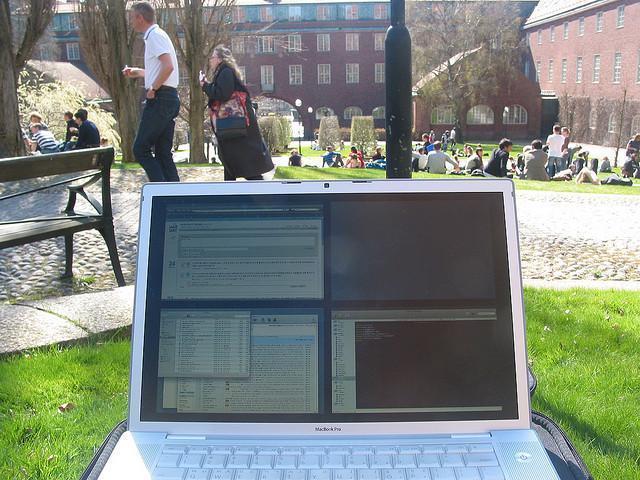Where is this lap top set up?
Select the correct answer and articulate reasoning with the following format: 'Answer: answer
Rationale: rationale.'
Options: Fire house, church, school, cemetery. Answer: school.
Rationale: The laptop is for school. 